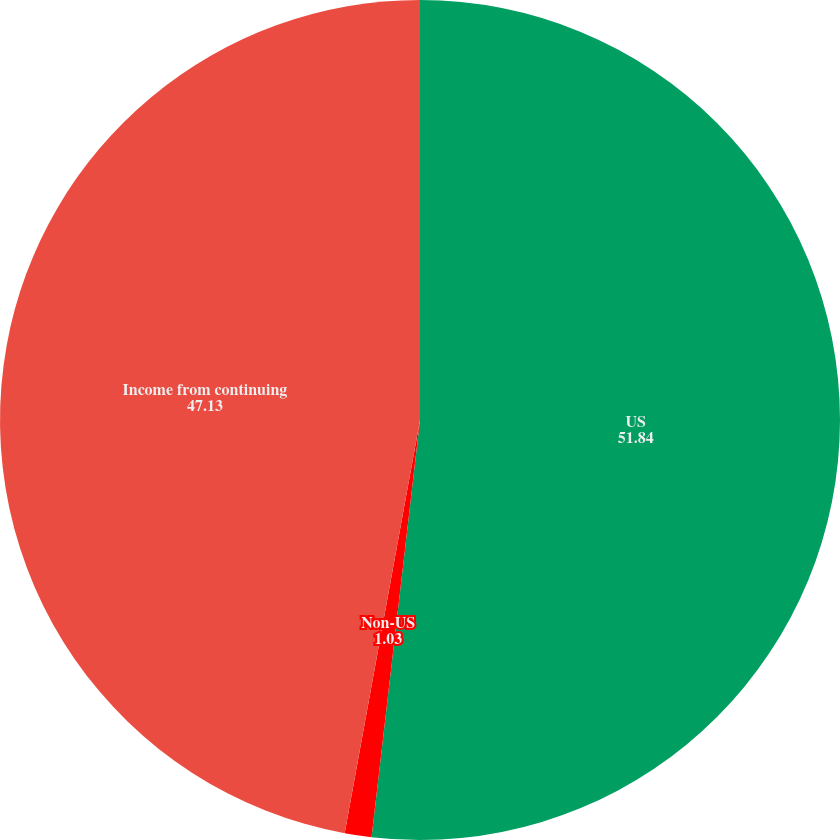Convert chart to OTSL. <chart><loc_0><loc_0><loc_500><loc_500><pie_chart><fcel>US<fcel>Non-US<fcel>Income from continuing<nl><fcel>51.84%<fcel>1.03%<fcel>47.13%<nl></chart> 